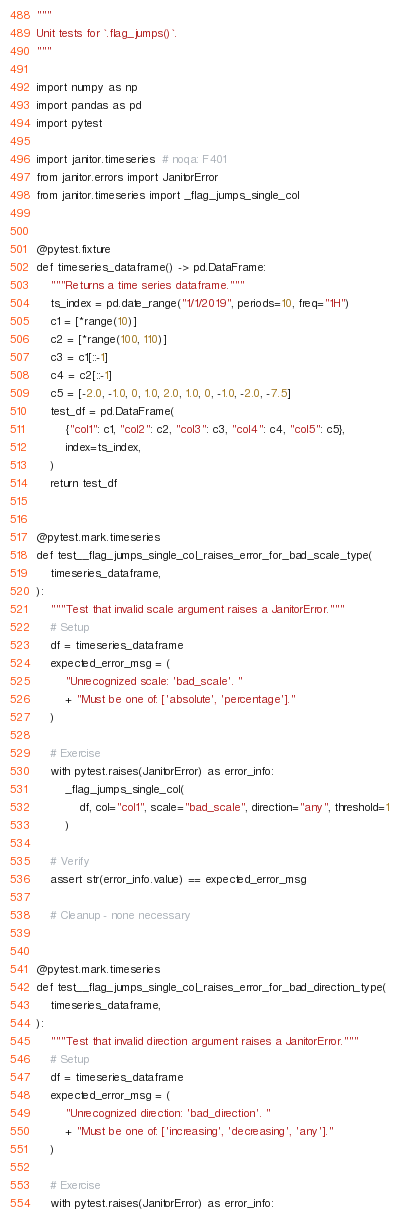<code> <loc_0><loc_0><loc_500><loc_500><_Python_>"""
Unit tests for `.flag_jumps()`.
"""

import numpy as np
import pandas as pd
import pytest

import janitor.timeseries  # noqa: F401
from janitor.errors import JanitorError
from janitor.timeseries import _flag_jumps_single_col


@pytest.fixture
def timeseries_dataframe() -> pd.DataFrame:
    """Returns a time series dataframe."""
    ts_index = pd.date_range("1/1/2019", periods=10, freq="1H")
    c1 = [*range(10)]
    c2 = [*range(100, 110)]
    c3 = c1[::-1]
    c4 = c2[::-1]
    c5 = [-2.0, -1.0, 0, 1.0, 2.0, 1.0, 0, -1.0, -2.0, -7.5]
    test_df = pd.DataFrame(
        {"col1": c1, "col2": c2, "col3": c3, "col4": c4, "col5": c5},
        index=ts_index,
    )
    return test_df


@pytest.mark.timeseries
def test__flag_jumps_single_col_raises_error_for_bad_scale_type(
    timeseries_dataframe,
):
    """Test that invalid scale argument raises a JanitorError."""
    # Setup
    df = timeseries_dataframe
    expected_error_msg = (
        "Unrecognized scale: 'bad_scale'. "
        + "Must be one of: ['absolute', 'percentage']."
    )

    # Exercise
    with pytest.raises(JanitorError) as error_info:
        _flag_jumps_single_col(
            df, col="col1", scale="bad_scale", direction="any", threshold=1
        )

    # Verify
    assert str(error_info.value) == expected_error_msg

    # Cleanup - none necessary


@pytest.mark.timeseries
def test__flag_jumps_single_col_raises_error_for_bad_direction_type(
    timeseries_dataframe,
):
    """Test that invalid direction argument raises a JanitorError."""
    # Setup
    df = timeseries_dataframe
    expected_error_msg = (
        "Unrecognized direction: 'bad_direction'. "
        + "Must be one of: ['increasing', 'decreasing', 'any']."
    )

    # Exercise
    with pytest.raises(JanitorError) as error_info:</code> 